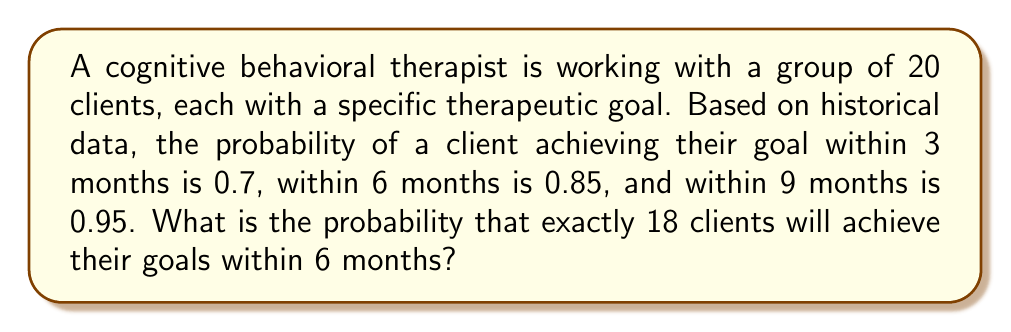Give your solution to this math problem. To solve this problem, we'll use the binomial probability formula:

$$ P(X = k) = \binom{n}{k} p^k (1-p)^{n-k} $$

Where:
$n$ = total number of clients = 20
$k$ = number of successful clients = 18
$p$ = probability of success within 6 months = 0.85

Step 1: Calculate the binomial coefficient:
$$ \binom{20}{18} = \frac{20!}{18!(20-18)!} = \frac{20!}{18!2!} = 190 $$

Step 2: Calculate $p^k$:
$$ 0.85^{18} \approx 0.0432 $$

Step 3: Calculate $(1-p)^{n-k}$:
$$ (1-0.85)^{20-18} = 0.15^2 = 0.0225 $$

Step 4: Multiply all components:
$$ P(X = 18) = 190 \times 0.0432 \times 0.0225 \approx 0.1848 $$

Therefore, the probability of exactly 18 clients achieving their goals within 6 months is approximately 0.1848 or 18.48%.
Answer: $0.1848$ 